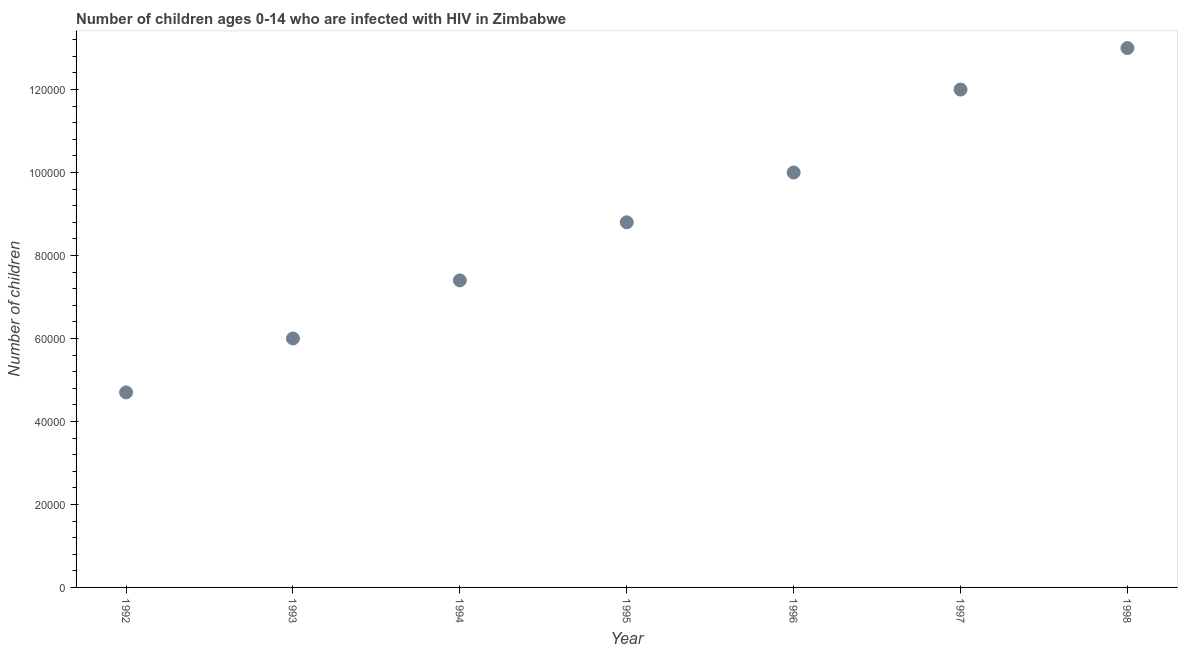What is the number of children living with hiv in 1993?
Your response must be concise. 6.00e+04. Across all years, what is the maximum number of children living with hiv?
Your answer should be compact. 1.30e+05. Across all years, what is the minimum number of children living with hiv?
Offer a terse response. 4.70e+04. In which year was the number of children living with hiv maximum?
Provide a succinct answer. 1998. In which year was the number of children living with hiv minimum?
Offer a very short reply. 1992. What is the sum of the number of children living with hiv?
Ensure brevity in your answer.  6.19e+05. What is the difference between the number of children living with hiv in 1994 and 1996?
Make the answer very short. -2.60e+04. What is the average number of children living with hiv per year?
Make the answer very short. 8.84e+04. What is the median number of children living with hiv?
Provide a short and direct response. 8.80e+04. What is the ratio of the number of children living with hiv in 1993 to that in 1994?
Provide a succinct answer. 0.81. Is the difference between the number of children living with hiv in 1992 and 1993 greater than the difference between any two years?
Your response must be concise. No. What is the difference between the highest and the second highest number of children living with hiv?
Your response must be concise. 10000. What is the difference between the highest and the lowest number of children living with hiv?
Your answer should be compact. 8.30e+04. In how many years, is the number of children living with hiv greater than the average number of children living with hiv taken over all years?
Offer a terse response. 3. Does the number of children living with hiv monotonically increase over the years?
Provide a succinct answer. Yes. How many dotlines are there?
Ensure brevity in your answer.  1. What is the difference between two consecutive major ticks on the Y-axis?
Make the answer very short. 2.00e+04. Does the graph contain any zero values?
Give a very brief answer. No. What is the title of the graph?
Your answer should be very brief. Number of children ages 0-14 who are infected with HIV in Zimbabwe. What is the label or title of the X-axis?
Your answer should be very brief. Year. What is the label or title of the Y-axis?
Give a very brief answer. Number of children. What is the Number of children in 1992?
Ensure brevity in your answer.  4.70e+04. What is the Number of children in 1993?
Provide a succinct answer. 6.00e+04. What is the Number of children in 1994?
Provide a short and direct response. 7.40e+04. What is the Number of children in 1995?
Your response must be concise. 8.80e+04. What is the Number of children in 1996?
Ensure brevity in your answer.  1.00e+05. What is the Number of children in 1997?
Give a very brief answer. 1.20e+05. What is the difference between the Number of children in 1992 and 1993?
Your response must be concise. -1.30e+04. What is the difference between the Number of children in 1992 and 1994?
Ensure brevity in your answer.  -2.70e+04. What is the difference between the Number of children in 1992 and 1995?
Your answer should be very brief. -4.10e+04. What is the difference between the Number of children in 1992 and 1996?
Ensure brevity in your answer.  -5.30e+04. What is the difference between the Number of children in 1992 and 1997?
Provide a succinct answer. -7.30e+04. What is the difference between the Number of children in 1992 and 1998?
Your response must be concise. -8.30e+04. What is the difference between the Number of children in 1993 and 1994?
Ensure brevity in your answer.  -1.40e+04. What is the difference between the Number of children in 1993 and 1995?
Make the answer very short. -2.80e+04. What is the difference between the Number of children in 1993 and 1996?
Offer a very short reply. -4.00e+04. What is the difference between the Number of children in 1994 and 1995?
Provide a short and direct response. -1.40e+04. What is the difference between the Number of children in 1994 and 1996?
Your answer should be compact. -2.60e+04. What is the difference between the Number of children in 1994 and 1997?
Your answer should be very brief. -4.60e+04. What is the difference between the Number of children in 1994 and 1998?
Provide a short and direct response. -5.60e+04. What is the difference between the Number of children in 1995 and 1996?
Your answer should be compact. -1.20e+04. What is the difference between the Number of children in 1995 and 1997?
Ensure brevity in your answer.  -3.20e+04. What is the difference between the Number of children in 1995 and 1998?
Provide a succinct answer. -4.20e+04. What is the difference between the Number of children in 1996 and 1998?
Your answer should be compact. -3.00e+04. What is the difference between the Number of children in 1997 and 1998?
Offer a very short reply. -10000. What is the ratio of the Number of children in 1992 to that in 1993?
Provide a short and direct response. 0.78. What is the ratio of the Number of children in 1992 to that in 1994?
Give a very brief answer. 0.64. What is the ratio of the Number of children in 1992 to that in 1995?
Provide a short and direct response. 0.53. What is the ratio of the Number of children in 1992 to that in 1996?
Offer a very short reply. 0.47. What is the ratio of the Number of children in 1992 to that in 1997?
Your response must be concise. 0.39. What is the ratio of the Number of children in 1992 to that in 1998?
Offer a terse response. 0.36. What is the ratio of the Number of children in 1993 to that in 1994?
Your response must be concise. 0.81. What is the ratio of the Number of children in 1993 to that in 1995?
Your response must be concise. 0.68. What is the ratio of the Number of children in 1993 to that in 1998?
Give a very brief answer. 0.46. What is the ratio of the Number of children in 1994 to that in 1995?
Your answer should be compact. 0.84. What is the ratio of the Number of children in 1994 to that in 1996?
Ensure brevity in your answer.  0.74. What is the ratio of the Number of children in 1994 to that in 1997?
Your answer should be very brief. 0.62. What is the ratio of the Number of children in 1994 to that in 1998?
Give a very brief answer. 0.57. What is the ratio of the Number of children in 1995 to that in 1996?
Your response must be concise. 0.88. What is the ratio of the Number of children in 1995 to that in 1997?
Provide a short and direct response. 0.73. What is the ratio of the Number of children in 1995 to that in 1998?
Provide a short and direct response. 0.68. What is the ratio of the Number of children in 1996 to that in 1997?
Offer a very short reply. 0.83. What is the ratio of the Number of children in 1996 to that in 1998?
Ensure brevity in your answer.  0.77. What is the ratio of the Number of children in 1997 to that in 1998?
Your response must be concise. 0.92. 